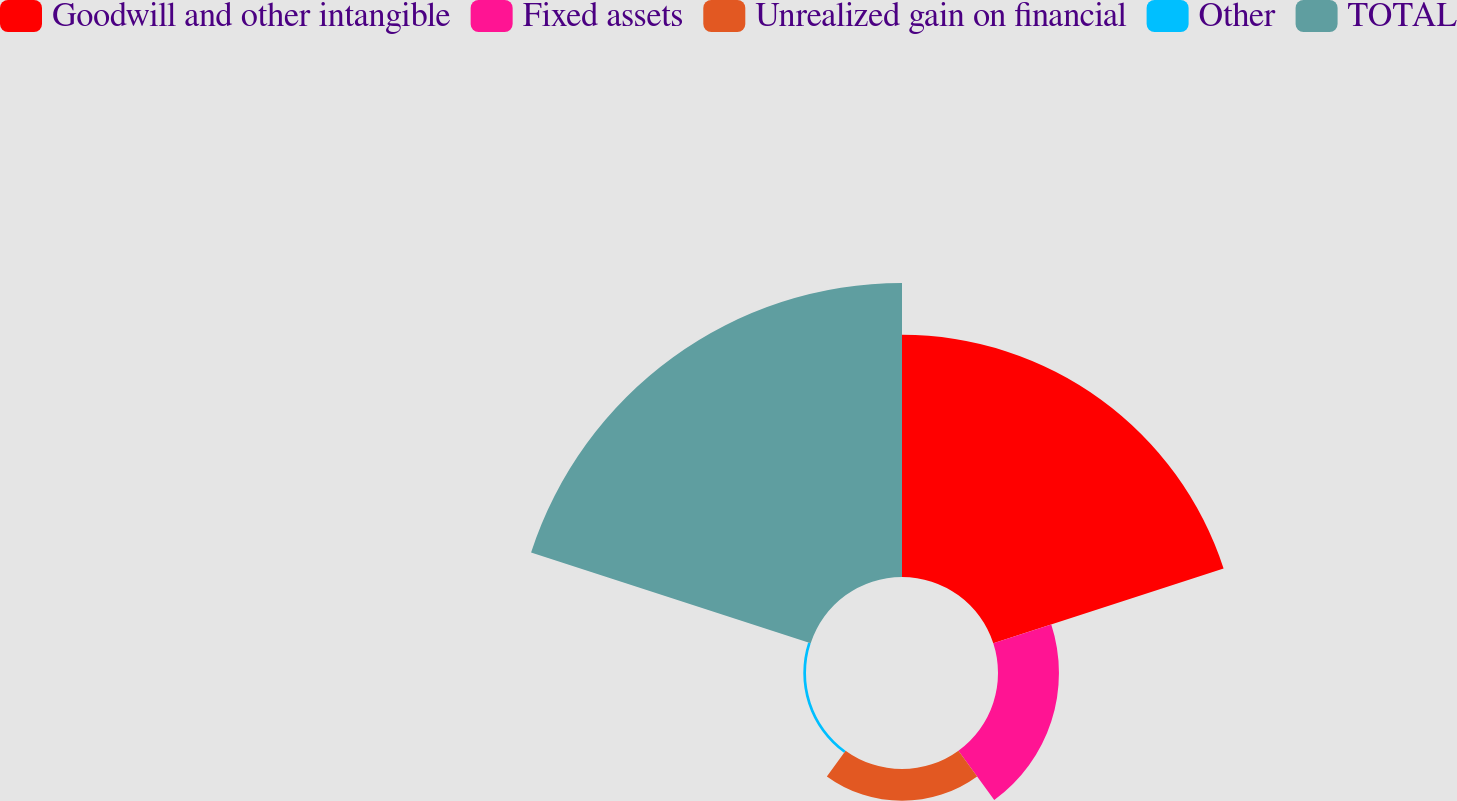Convert chart. <chart><loc_0><loc_0><loc_500><loc_500><pie_chart><fcel>Goodwill and other intangible<fcel>Fixed assets<fcel>Unrealized gain on financial<fcel>Other<fcel>TOTAL<nl><fcel>38.34%<fcel>9.65%<fcel>5.04%<fcel>0.43%<fcel>46.55%<nl></chart> 